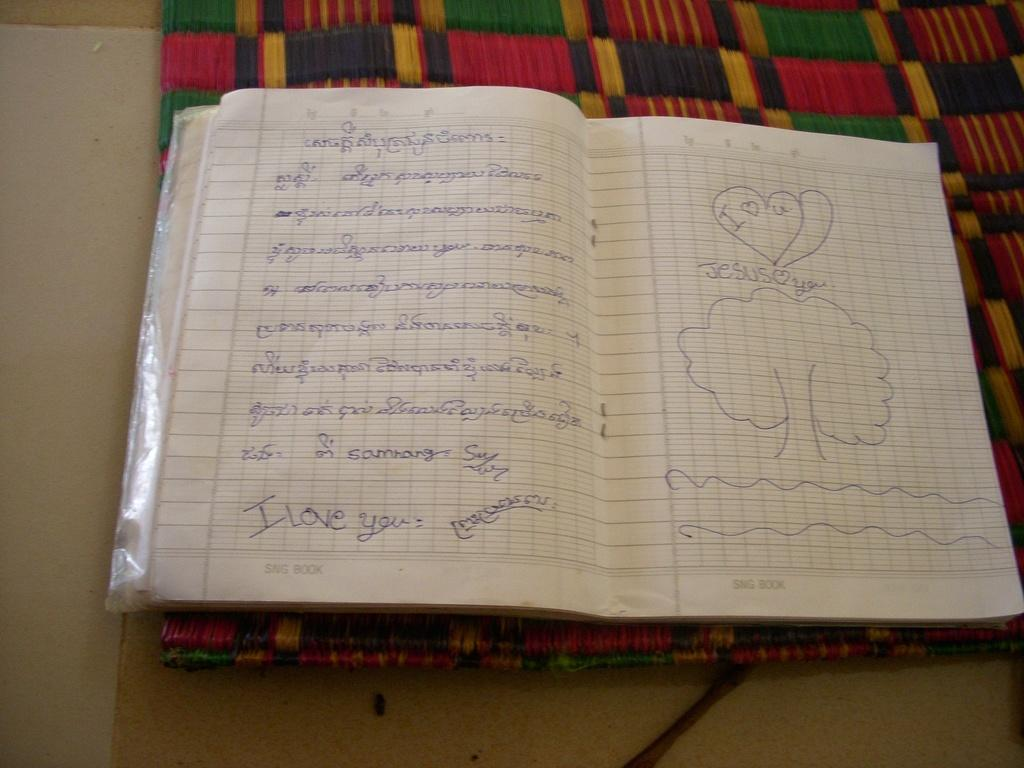<image>
Share a concise interpretation of the image provided. Notebook that says I love you and Jesus love you, 